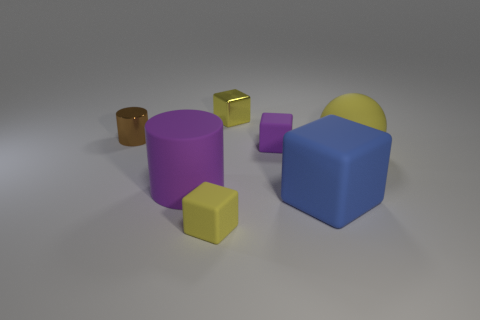Add 1 big purple metallic spheres. How many objects exist? 8 Subtract all cubes. How many objects are left? 3 Subtract 0 gray blocks. How many objects are left? 7 Subtract all large things. Subtract all rubber blocks. How many objects are left? 1 Add 1 large yellow things. How many large yellow things are left? 2 Add 6 brown shiny cylinders. How many brown shiny cylinders exist? 7 